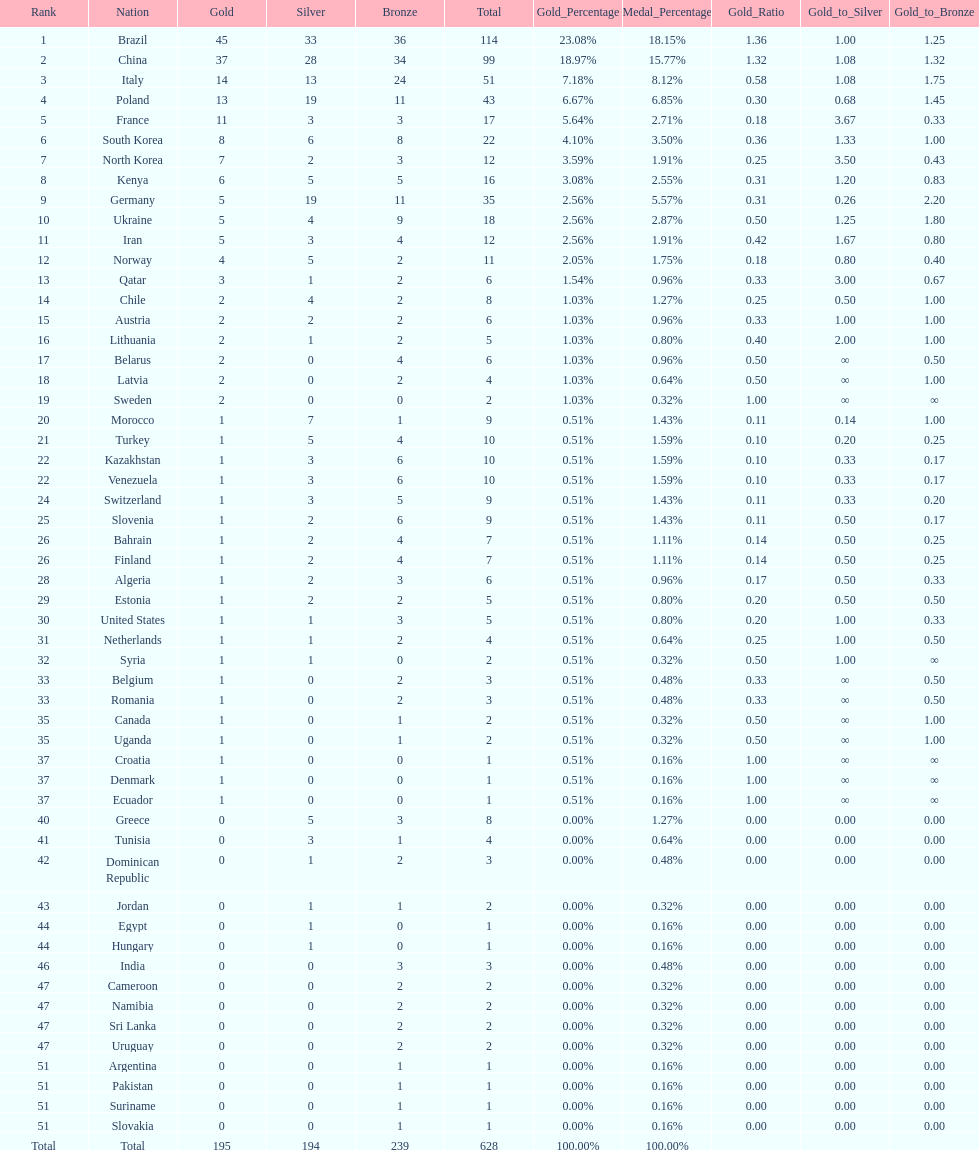Did italy or norway have 51 total medals? Italy. 